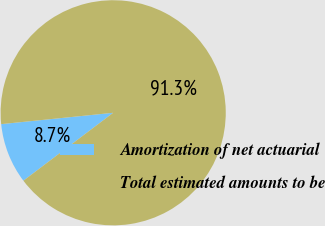Convert chart to OTSL. <chart><loc_0><loc_0><loc_500><loc_500><pie_chart><fcel>Amortization of net actuarial<fcel>Total estimated amounts to be<nl><fcel>8.7%<fcel>91.3%<nl></chart> 